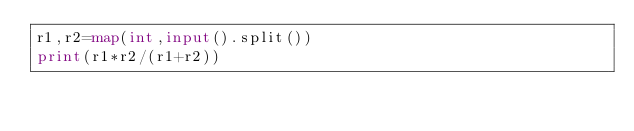Convert code to text. <code><loc_0><loc_0><loc_500><loc_500><_Python_>r1,r2=map(int,input().split())
print(r1*r2/(r1+r2))</code> 